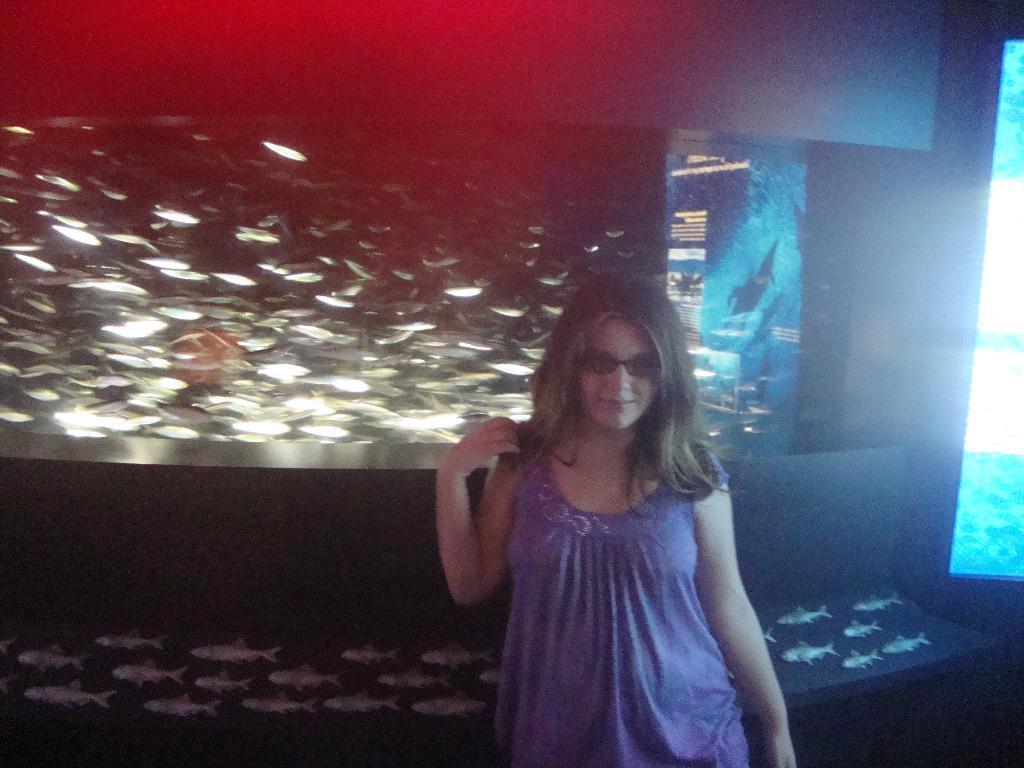Can you describe this image briefly? In this picture we can see a woman wearing spectacles, behind we can see a screen, in which we can see some fishes. 